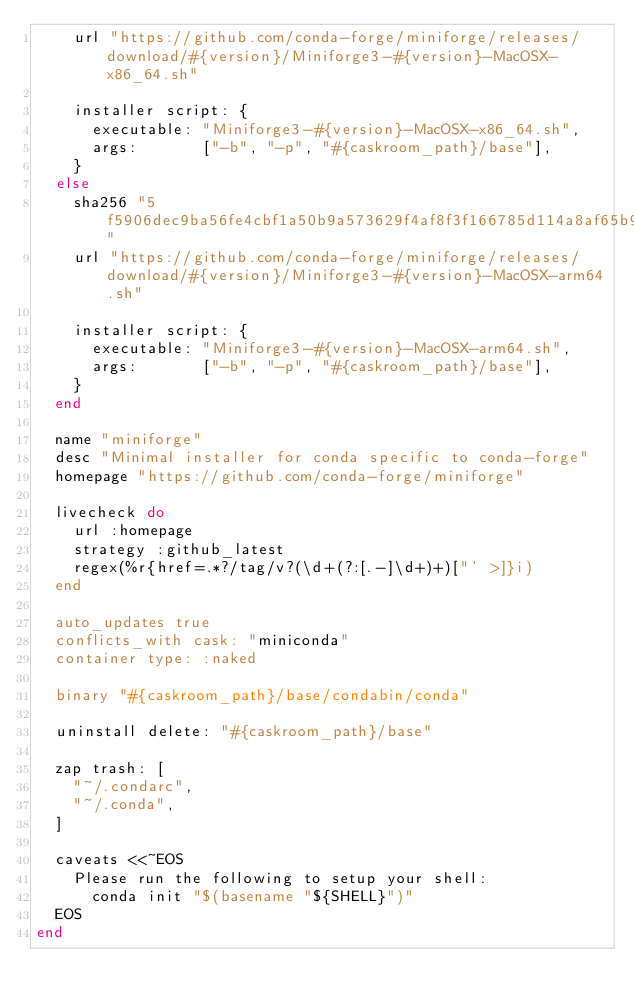Convert code to text. <code><loc_0><loc_0><loc_500><loc_500><_Ruby_>    url "https://github.com/conda-forge/miniforge/releases/download/#{version}/Miniforge3-#{version}-MacOSX-x86_64.sh"

    installer script: {
      executable: "Miniforge3-#{version}-MacOSX-x86_64.sh",
      args:       ["-b", "-p", "#{caskroom_path}/base"],
    }
  else
    sha256 "5f5906dec9ba56fe4cbf1a50b9a573629f4af8f3f166785d114a8af65b9c78a3"
    url "https://github.com/conda-forge/miniforge/releases/download/#{version}/Miniforge3-#{version}-MacOSX-arm64.sh"

    installer script: {
      executable: "Miniforge3-#{version}-MacOSX-arm64.sh",
      args:       ["-b", "-p", "#{caskroom_path}/base"],
    }
  end

  name "miniforge"
  desc "Minimal installer for conda specific to conda-forge"
  homepage "https://github.com/conda-forge/miniforge"

  livecheck do
    url :homepage
    strategy :github_latest
    regex(%r{href=.*?/tag/v?(\d+(?:[.-]\d+)+)["' >]}i)
  end

  auto_updates true
  conflicts_with cask: "miniconda"
  container type: :naked

  binary "#{caskroom_path}/base/condabin/conda"

  uninstall delete: "#{caskroom_path}/base"

  zap trash: [
    "~/.condarc",
    "~/.conda",
  ]

  caveats <<~EOS
    Please run the following to setup your shell:
      conda init "$(basename "${SHELL}")"
  EOS
end
</code> 